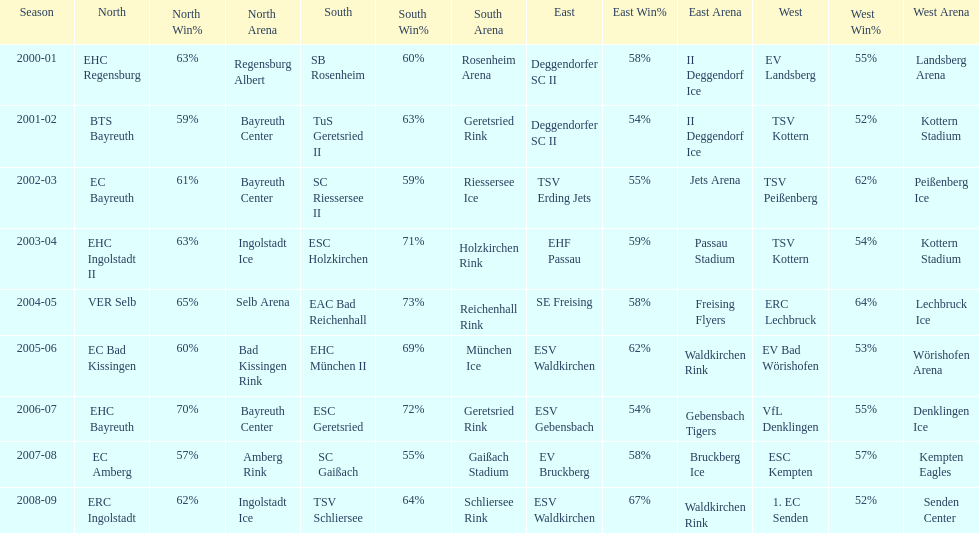How many champions are listend in the north? 9. 